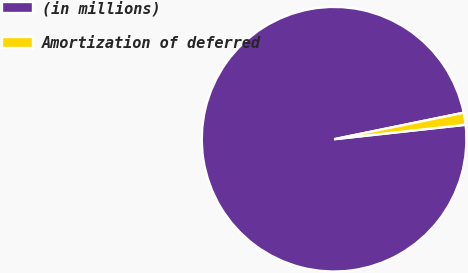<chart> <loc_0><loc_0><loc_500><loc_500><pie_chart><fcel>(in millions)<fcel>Amortization of deferred<nl><fcel>98.53%<fcel>1.47%<nl></chart> 